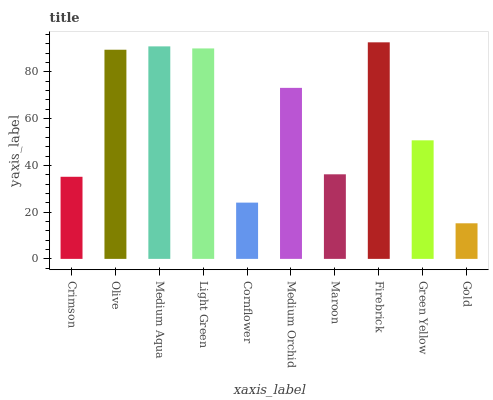Is Gold the minimum?
Answer yes or no. Yes. Is Firebrick the maximum?
Answer yes or no. Yes. Is Olive the minimum?
Answer yes or no. No. Is Olive the maximum?
Answer yes or no. No. Is Olive greater than Crimson?
Answer yes or no. Yes. Is Crimson less than Olive?
Answer yes or no. Yes. Is Crimson greater than Olive?
Answer yes or no. No. Is Olive less than Crimson?
Answer yes or no. No. Is Medium Orchid the high median?
Answer yes or no. Yes. Is Green Yellow the low median?
Answer yes or no. Yes. Is Olive the high median?
Answer yes or no. No. Is Crimson the low median?
Answer yes or no. No. 